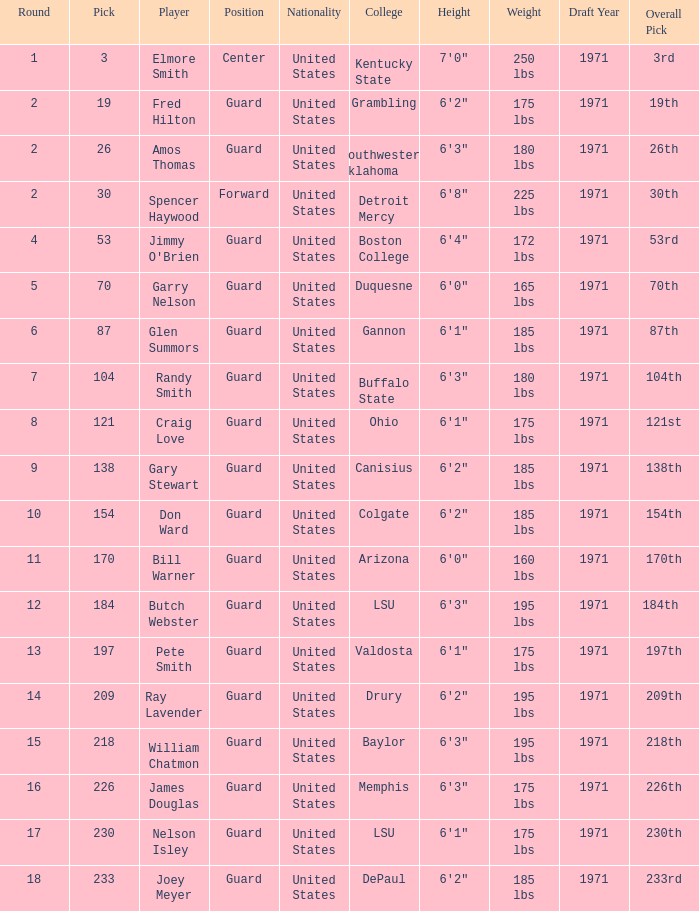WHAT IS THE NATIONALITY FOR SOUTHWESTERN OKLAHOMA? United States. 